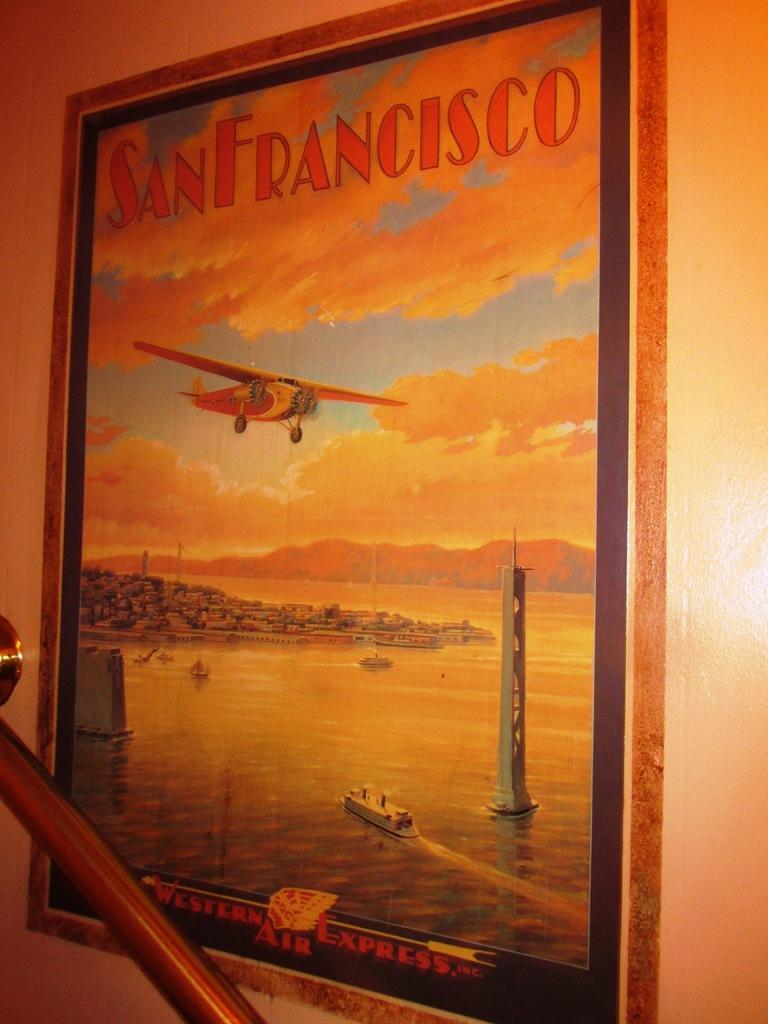Please provide a concise description of this image. In this image there is a wall for that wall there is a frame, on that frame there is text, airplane, sky, sea, ship and tower. 